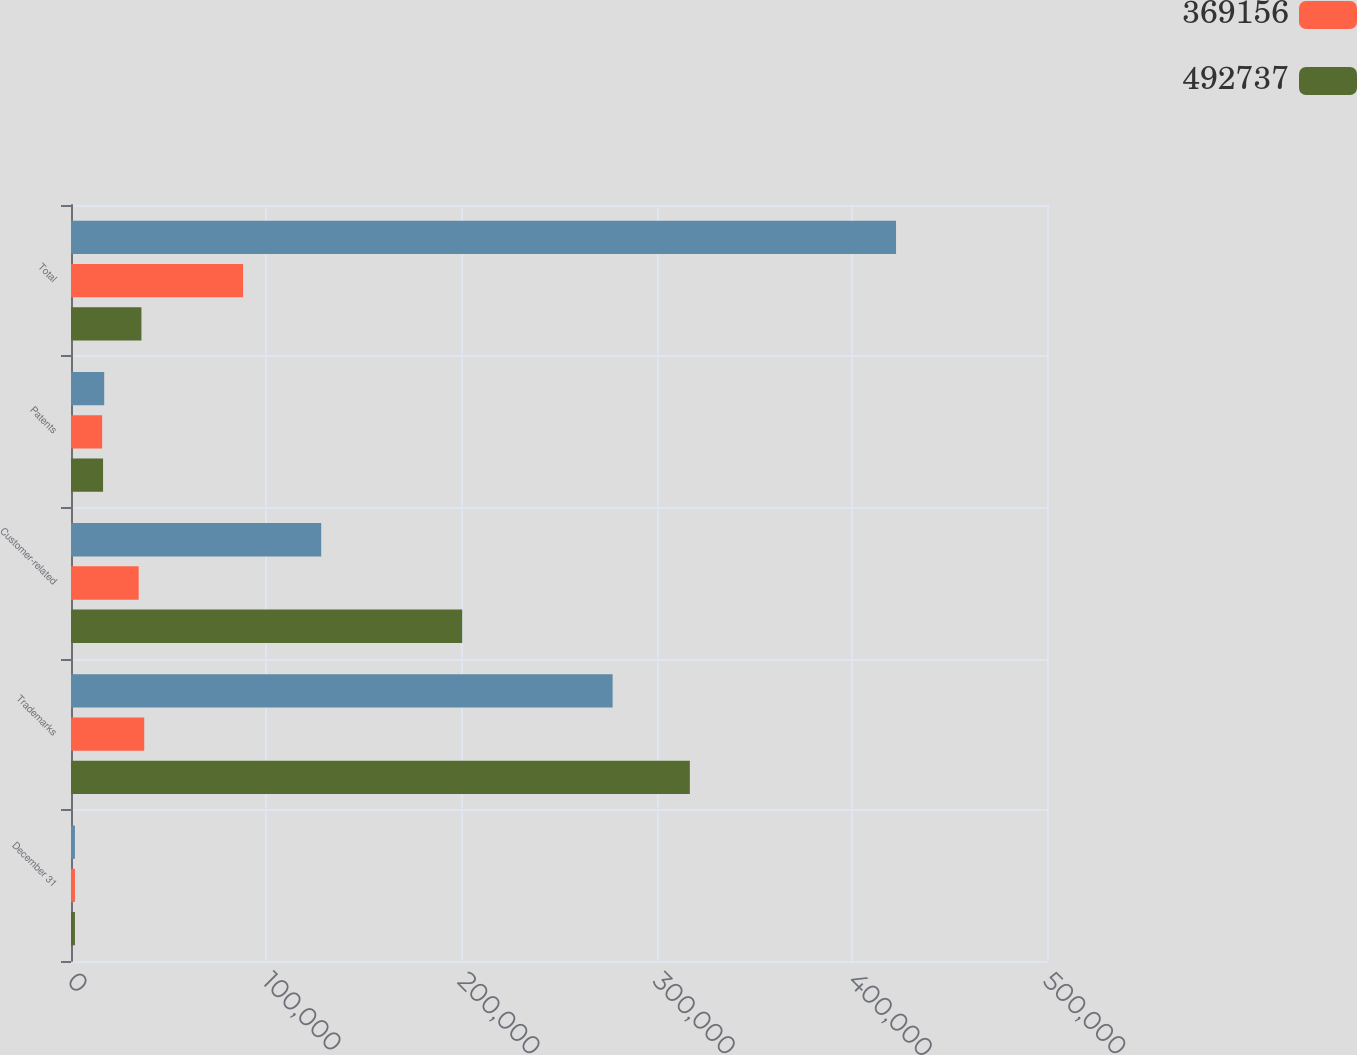<chart> <loc_0><loc_0><loc_500><loc_500><stacked_bar_chart><ecel><fcel>December 31<fcel>Trademarks<fcel>Customer-related<fcel>Patents<fcel>Total<nl><fcel>nan<fcel>2017<fcel>277473<fcel>128182<fcel>17009<fcel>422664<nl><fcel>369156<fcel>2017<fcel>37510<fcel>34659<fcel>15975<fcel>88144<nl><fcel>492737<fcel>2016<fcel>317023<fcel>200409<fcel>16426<fcel>36084.5<nl></chart> 